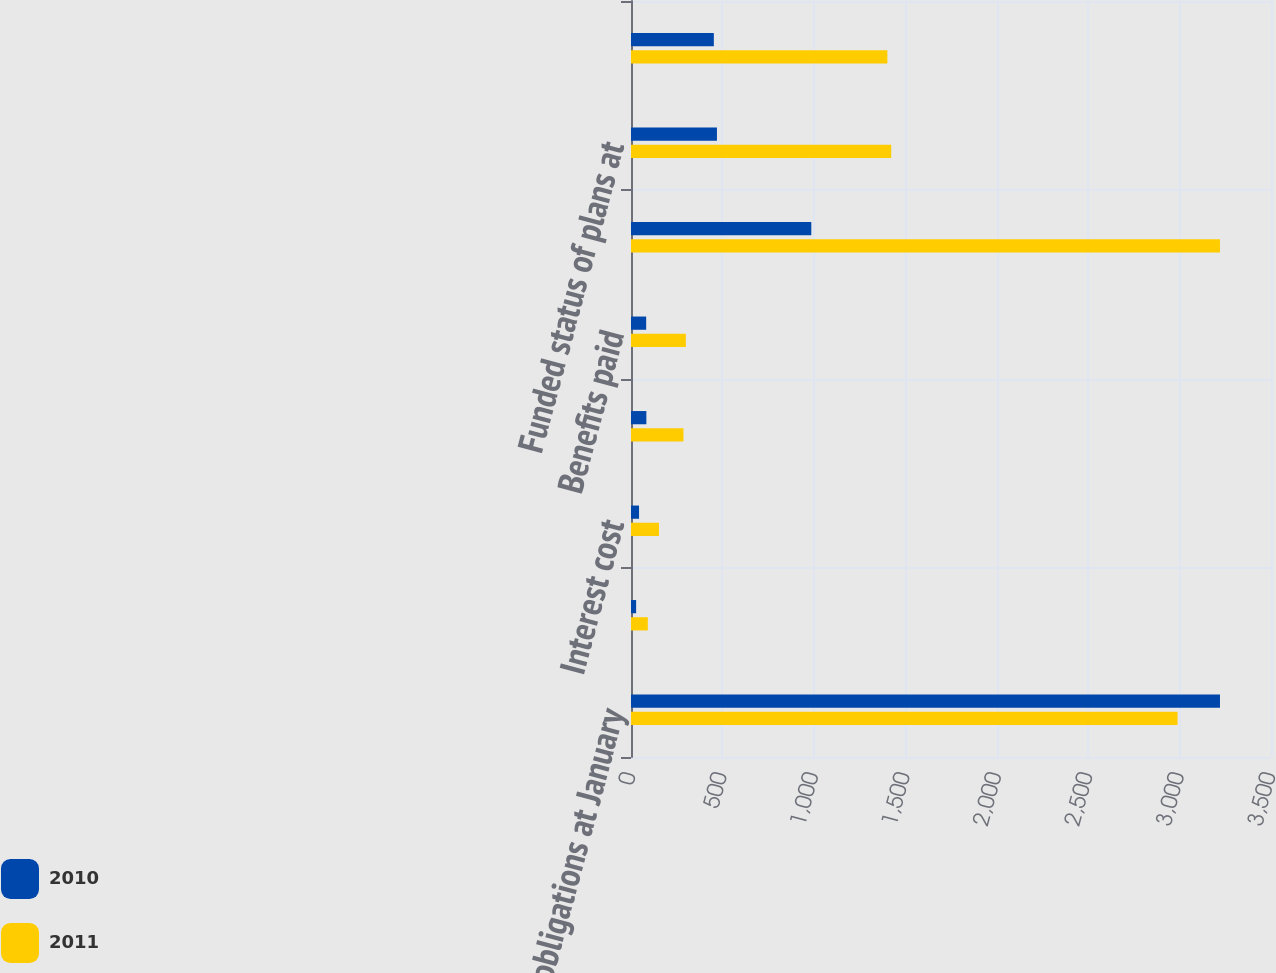Convert chart to OTSL. <chart><loc_0><loc_0><loc_500><loc_500><stacked_bar_chart><ecel><fcel>Benefit obligations at January<fcel>Service cost<fcel>Interest cost<fcel>Actuarial loss<fcel>Benefits paid<fcel>Benefit obligations at<fcel>Funded status of plans at<fcel>Noncurrent liabilities<nl><fcel>2010<fcel>3221<fcel>28<fcel>44<fcel>84<fcel>83<fcel>986<fcel>470<fcel>453<nl><fcel>2011<fcel>2989<fcel>92<fcel>153<fcel>287<fcel>300<fcel>3221<fcel>1423<fcel>1402<nl></chart> 